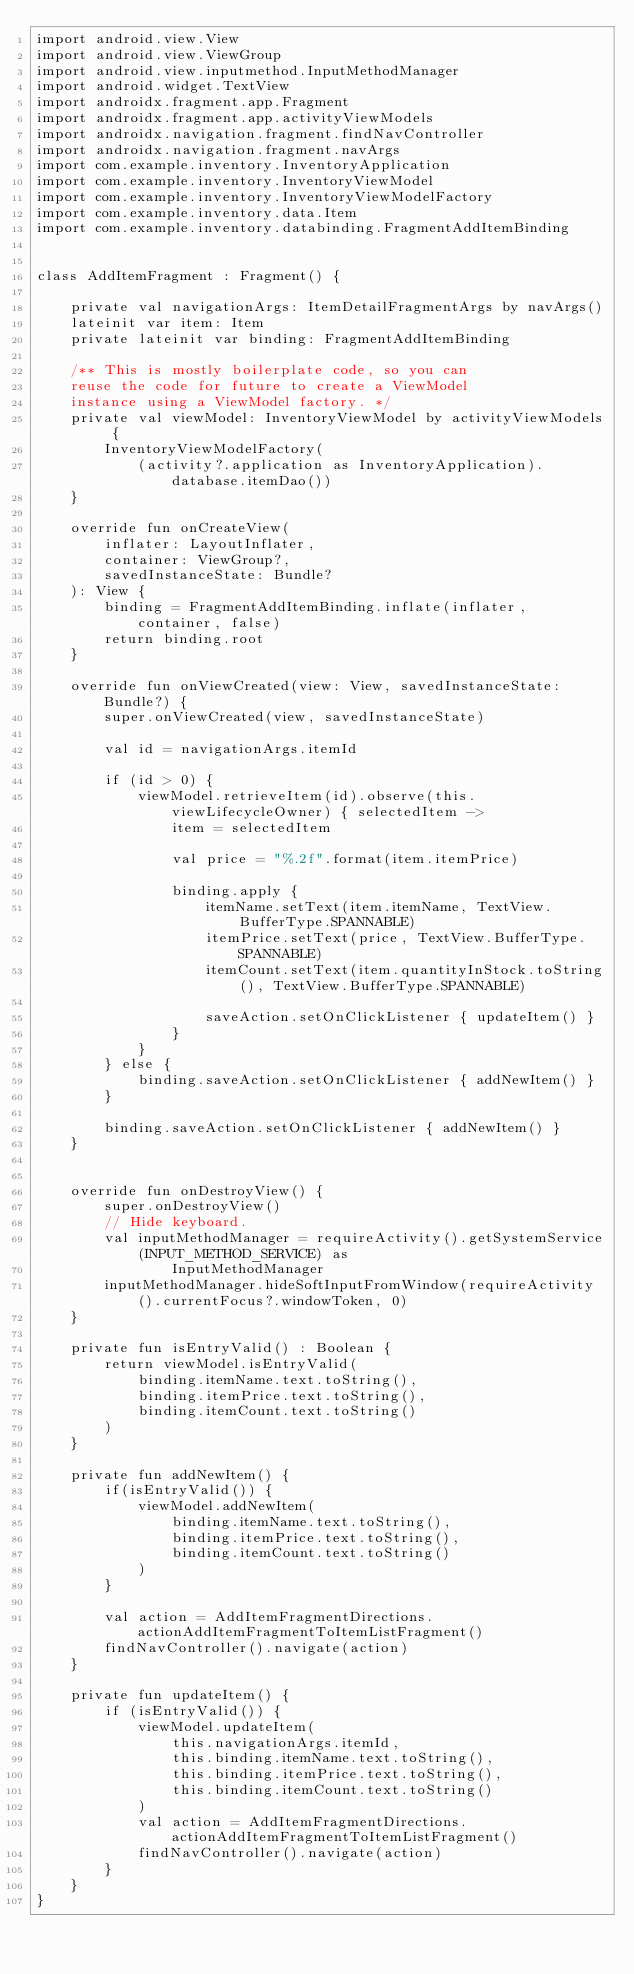<code> <loc_0><loc_0><loc_500><loc_500><_Kotlin_>import android.view.View
import android.view.ViewGroup
import android.view.inputmethod.InputMethodManager
import android.widget.TextView
import androidx.fragment.app.Fragment
import androidx.fragment.app.activityViewModels
import androidx.navigation.fragment.findNavController
import androidx.navigation.fragment.navArgs
import com.example.inventory.InventoryApplication
import com.example.inventory.InventoryViewModel
import com.example.inventory.InventoryViewModelFactory
import com.example.inventory.data.Item
import com.example.inventory.databinding.FragmentAddItemBinding


class AddItemFragment : Fragment() {

    private val navigationArgs: ItemDetailFragmentArgs by navArgs()
    lateinit var item: Item
    private lateinit var binding: FragmentAddItemBinding

    /** This is mostly boilerplate code, so you can
    reuse the code for future to create a ViewModel
    instance using a ViewModel factory. */
    private val viewModel: InventoryViewModel by activityViewModels {
        InventoryViewModelFactory(
            (activity?.application as InventoryApplication).database.itemDao())
    }

    override fun onCreateView(
        inflater: LayoutInflater,
        container: ViewGroup?,
        savedInstanceState: Bundle?
    ): View {
        binding = FragmentAddItemBinding.inflate(inflater, container, false)
        return binding.root
    }

    override fun onViewCreated(view: View, savedInstanceState: Bundle?) {
        super.onViewCreated(view, savedInstanceState)

        val id = navigationArgs.itemId

        if (id > 0) {
            viewModel.retrieveItem(id).observe(this.viewLifecycleOwner) { selectedItem ->
                item = selectedItem

                val price = "%.2f".format(item.itemPrice)

                binding.apply {
                    itemName.setText(item.itemName, TextView.BufferType.SPANNABLE)
                    itemPrice.setText(price, TextView.BufferType.SPANNABLE)
                    itemCount.setText(item.quantityInStock.toString(), TextView.BufferType.SPANNABLE)

                    saveAction.setOnClickListener { updateItem() }
                }
            }
        } else {
            binding.saveAction.setOnClickListener { addNewItem() }
        }

        binding.saveAction.setOnClickListener { addNewItem() }
    }


    override fun onDestroyView() {
        super.onDestroyView()
        // Hide keyboard.
        val inputMethodManager = requireActivity().getSystemService(INPUT_METHOD_SERVICE) as
                InputMethodManager
        inputMethodManager.hideSoftInputFromWindow(requireActivity().currentFocus?.windowToken, 0)
    }

    private fun isEntryValid() : Boolean {
        return viewModel.isEntryValid(
            binding.itemName.text.toString(),
            binding.itemPrice.text.toString(),
            binding.itemCount.text.toString()
        )
    }

    private fun addNewItem() {
        if(isEntryValid()) {
            viewModel.addNewItem(
                binding.itemName.text.toString(),
                binding.itemPrice.text.toString(),
                binding.itemCount.text.toString()
            )
        }

        val action = AddItemFragmentDirections.actionAddItemFragmentToItemListFragment()
        findNavController().navigate(action)
    }

    private fun updateItem() {
        if (isEntryValid()) {
            viewModel.updateItem(
                this.navigationArgs.itemId,
                this.binding.itemName.text.toString(),
                this.binding.itemPrice.text.toString(),
                this.binding.itemCount.text.toString()
            )
            val action = AddItemFragmentDirections.actionAddItemFragmentToItemListFragment()
            findNavController().navigate(action)
        }
    }
}
</code> 